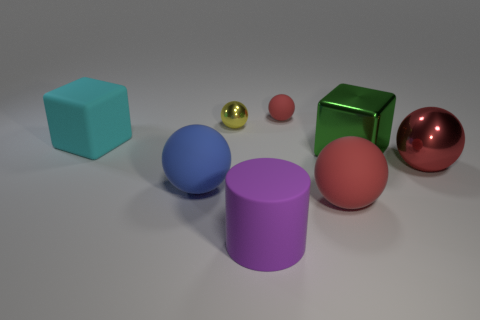What color is the rubber cylinder that is the same size as the green thing? The rubber cylinder that matches the green cube in size is purple in color, with a smooth texture and solid appearance, indicating it may be similar in material to the other objects in the scene. 